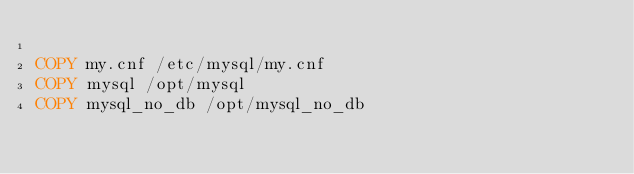Convert code to text. <code><loc_0><loc_0><loc_500><loc_500><_Dockerfile_>
COPY my.cnf /etc/mysql/my.cnf
COPY mysql /opt/mysql
COPY mysql_no_db /opt/mysql_no_db
</code> 